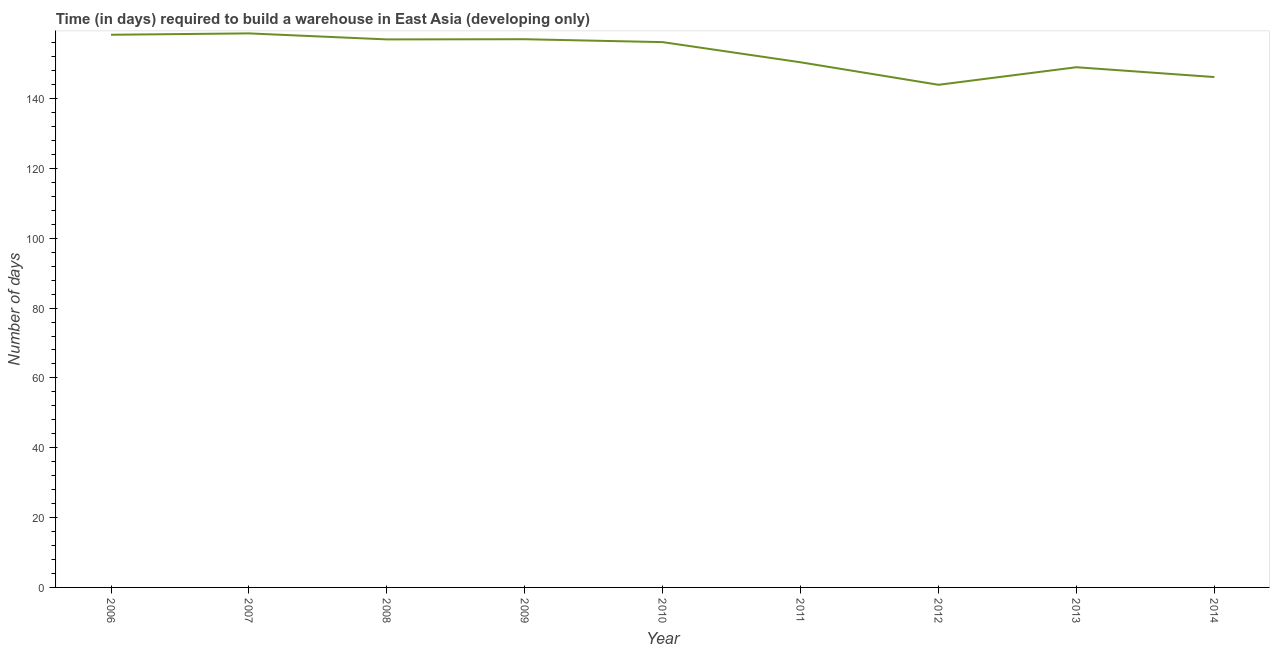What is the time required to build a warehouse in 2010?
Make the answer very short. 156.17. Across all years, what is the maximum time required to build a warehouse?
Your answer should be very brief. 158.67. Across all years, what is the minimum time required to build a warehouse?
Your answer should be compact. 143.95. In which year was the time required to build a warehouse maximum?
Keep it short and to the point. 2007. In which year was the time required to build a warehouse minimum?
Give a very brief answer. 2012. What is the sum of the time required to build a warehouse?
Give a very brief answer. 1376.53. What is the difference between the time required to build a warehouse in 2008 and 2013?
Make the answer very short. 7.97. What is the average time required to build a warehouse per year?
Provide a succinct answer. 152.95. What is the median time required to build a warehouse?
Make the answer very short. 156.17. In how many years, is the time required to build a warehouse greater than 132 days?
Ensure brevity in your answer.  9. Do a majority of the years between 2012 and 2008 (inclusive) have time required to build a warehouse greater than 104 days?
Keep it short and to the point. Yes. What is the ratio of the time required to build a warehouse in 2009 to that in 2014?
Keep it short and to the point. 1.07. Is the difference between the time required to build a warehouse in 2010 and 2011 greater than the difference between any two years?
Your answer should be very brief. No. What is the difference between the highest and the second highest time required to build a warehouse?
Offer a very short reply. 0.39. Is the sum of the time required to build a warehouse in 2012 and 2013 greater than the maximum time required to build a warehouse across all years?
Give a very brief answer. Yes. What is the difference between the highest and the lowest time required to build a warehouse?
Your answer should be very brief. 14.72. Does the graph contain any zero values?
Keep it short and to the point. No. Does the graph contain grids?
Your answer should be very brief. No. What is the title of the graph?
Make the answer very short. Time (in days) required to build a warehouse in East Asia (developing only). What is the label or title of the Y-axis?
Your response must be concise. Number of days. What is the Number of days of 2006?
Provide a succinct answer. 158.28. What is the Number of days of 2007?
Offer a very short reply. 158.67. What is the Number of days of 2008?
Offer a terse response. 156.94. What is the Number of days of 2009?
Provide a short and direct response. 157. What is the Number of days of 2010?
Provide a succinct answer. 156.17. What is the Number of days in 2011?
Offer a very short reply. 150.39. What is the Number of days of 2012?
Your response must be concise. 143.95. What is the Number of days in 2013?
Offer a terse response. 148.98. What is the Number of days in 2014?
Make the answer very short. 146.17. What is the difference between the Number of days in 2006 and 2007?
Provide a succinct answer. -0.39. What is the difference between the Number of days in 2006 and 2008?
Offer a terse response. 1.33. What is the difference between the Number of days in 2006 and 2009?
Your answer should be compact. 1.28. What is the difference between the Number of days in 2006 and 2010?
Your answer should be compact. 2.11. What is the difference between the Number of days in 2006 and 2011?
Give a very brief answer. 7.89. What is the difference between the Number of days in 2006 and 2012?
Your answer should be very brief. 14.33. What is the difference between the Number of days in 2006 and 2013?
Offer a very short reply. 9.3. What is the difference between the Number of days in 2006 and 2014?
Your answer should be very brief. 12.11. What is the difference between the Number of days in 2007 and 2008?
Your answer should be compact. 1.72. What is the difference between the Number of days in 2007 and 2009?
Provide a short and direct response. 1.67. What is the difference between the Number of days in 2007 and 2011?
Your answer should be compact. 8.28. What is the difference between the Number of days in 2007 and 2012?
Ensure brevity in your answer.  14.72. What is the difference between the Number of days in 2007 and 2013?
Offer a very short reply. 9.69. What is the difference between the Number of days in 2007 and 2014?
Offer a terse response. 12.5. What is the difference between the Number of days in 2008 and 2009?
Ensure brevity in your answer.  -0.06. What is the difference between the Number of days in 2008 and 2010?
Your answer should be compact. 0.78. What is the difference between the Number of days in 2008 and 2011?
Your answer should be very brief. 6.56. What is the difference between the Number of days in 2008 and 2012?
Your answer should be very brief. 13. What is the difference between the Number of days in 2008 and 2013?
Make the answer very short. 7.97. What is the difference between the Number of days in 2008 and 2014?
Give a very brief answer. 10.78. What is the difference between the Number of days in 2009 and 2010?
Provide a short and direct response. 0.83. What is the difference between the Number of days in 2009 and 2011?
Offer a terse response. 6.61. What is the difference between the Number of days in 2009 and 2012?
Make the answer very short. 13.05. What is the difference between the Number of days in 2009 and 2013?
Your answer should be compact. 8.02. What is the difference between the Number of days in 2009 and 2014?
Keep it short and to the point. 10.83. What is the difference between the Number of days in 2010 and 2011?
Offer a very short reply. 5.78. What is the difference between the Number of days in 2010 and 2012?
Provide a succinct answer. 12.22. What is the difference between the Number of days in 2010 and 2013?
Keep it short and to the point. 7.19. What is the difference between the Number of days in 2010 and 2014?
Keep it short and to the point. 10. What is the difference between the Number of days in 2011 and 2012?
Your answer should be very brief. 6.44. What is the difference between the Number of days in 2011 and 2013?
Your answer should be very brief. 1.41. What is the difference between the Number of days in 2011 and 2014?
Ensure brevity in your answer.  4.22. What is the difference between the Number of days in 2012 and 2013?
Your answer should be compact. -5.03. What is the difference between the Number of days in 2012 and 2014?
Provide a succinct answer. -2.22. What is the difference between the Number of days in 2013 and 2014?
Offer a very short reply. 2.81. What is the ratio of the Number of days in 2006 to that in 2008?
Keep it short and to the point. 1.01. What is the ratio of the Number of days in 2006 to that in 2010?
Your answer should be compact. 1.01. What is the ratio of the Number of days in 2006 to that in 2011?
Give a very brief answer. 1.05. What is the ratio of the Number of days in 2006 to that in 2013?
Your answer should be very brief. 1.06. What is the ratio of the Number of days in 2006 to that in 2014?
Offer a very short reply. 1.08. What is the ratio of the Number of days in 2007 to that in 2011?
Give a very brief answer. 1.05. What is the ratio of the Number of days in 2007 to that in 2012?
Your answer should be compact. 1.1. What is the ratio of the Number of days in 2007 to that in 2013?
Keep it short and to the point. 1.06. What is the ratio of the Number of days in 2007 to that in 2014?
Give a very brief answer. 1.09. What is the ratio of the Number of days in 2008 to that in 2011?
Your answer should be compact. 1.04. What is the ratio of the Number of days in 2008 to that in 2012?
Offer a very short reply. 1.09. What is the ratio of the Number of days in 2008 to that in 2013?
Your answer should be very brief. 1.05. What is the ratio of the Number of days in 2008 to that in 2014?
Your response must be concise. 1.07. What is the ratio of the Number of days in 2009 to that in 2010?
Provide a succinct answer. 1. What is the ratio of the Number of days in 2009 to that in 2011?
Provide a succinct answer. 1.04. What is the ratio of the Number of days in 2009 to that in 2012?
Give a very brief answer. 1.09. What is the ratio of the Number of days in 2009 to that in 2013?
Your answer should be very brief. 1.05. What is the ratio of the Number of days in 2009 to that in 2014?
Provide a succinct answer. 1.07. What is the ratio of the Number of days in 2010 to that in 2011?
Provide a short and direct response. 1.04. What is the ratio of the Number of days in 2010 to that in 2012?
Your response must be concise. 1.08. What is the ratio of the Number of days in 2010 to that in 2013?
Your response must be concise. 1.05. What is the ratio of the Number of days in 2010 to that in 2014?
Your answer should be compact. 1.07. What is the ratio of the Number of days in 2011 to that in 2012?
Your answer should be compact. 1.04. What is the ratio of the Number of days in 2012 to that in 2013?
Offer a terse response. 0.97. What is the ratio of the Number of days in 2012 to that in 2014?
Offer a very short reply. 0.98. 